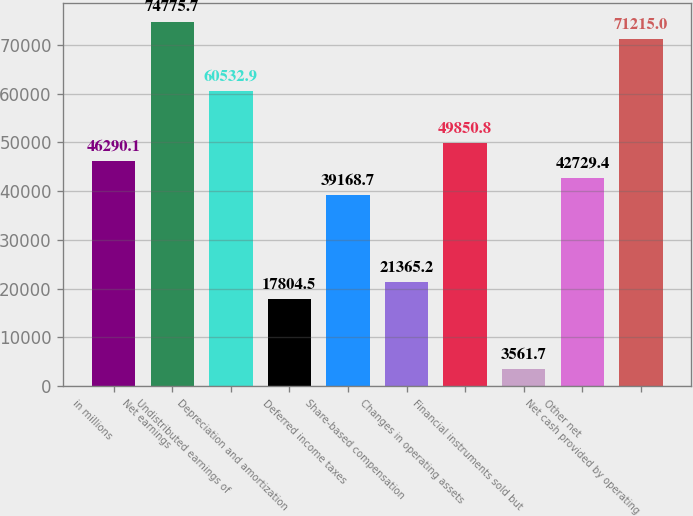Convert chart to OTSL. <chart><loc_0><loc_0><loc_500><loc_500><bar_chart><fcel>in millions<fcel>Net earnings<fcel>Undistributed earnings of<fcel>Depreciation and amortization<fcel>Deferred income taxes<fcel>Share-based compensation<fcel>Changes in operating assets<fcel>Financial instruments sold but<fcel>Other net<fcel>Net cash provided by operating<nl><fcel>46290.1<fcel>74775.7<fcel>60532.9<fcel>17804.5<fcel>39168.7<fcel>21365.2<fcel>49850.8<fcel>3561.7<fcel>42729.4<fcel>71215<nl></chart> 